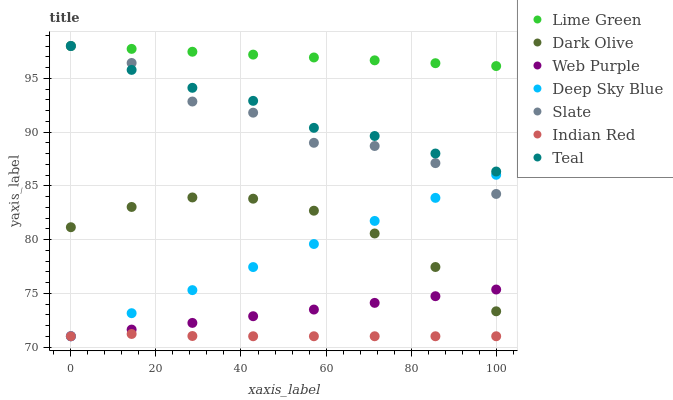Does Indian Red have the minimum area under the curve?
Answer yes or no. Yes. Does Lime Green have the maximum area under the curve?
Answer yes or no. Yes. Does Deep Sky Blue have the minimum area under the curve?
Answer yes or no. No. Does Deep Sky Blue have the maximum area under the curve?
Answer yes or no. No. Is Web Purple the smoothest?
Answer yes or no. Yes. Is Slate the roughest?
Answer yes or no. Yes. Is Deep Sky Blue the smoothest?
Answer yes or no. No. Is Deep Sky Blue the roughest?
Answer yes or no. No. Does Deep Sky Blue have the lowest value?
Answer yes or no. Yes. Does Slate have the lowest value?
Answer yes or no. No. Does Lime Green have the highest value?
Answer yes or no. Yes. Does Deep Sky Blue have the highest value?
Answer yes or no. No. Is Web Purple less than Lime Green?
Answer yes or no. Yes. Is Slate greater than Dark Olive?
Answer yes or no. Yes. Does Indian Red intersect Web Purple?
Answer yes or no. Yes. Is Indian Red less than Web Purple?
Answer yes or no. No. Is Indian Red greater than Web Purple?
Answer yes or no. No. Does Web Purple intersect Lime Green?
Answer yes or no. No. 